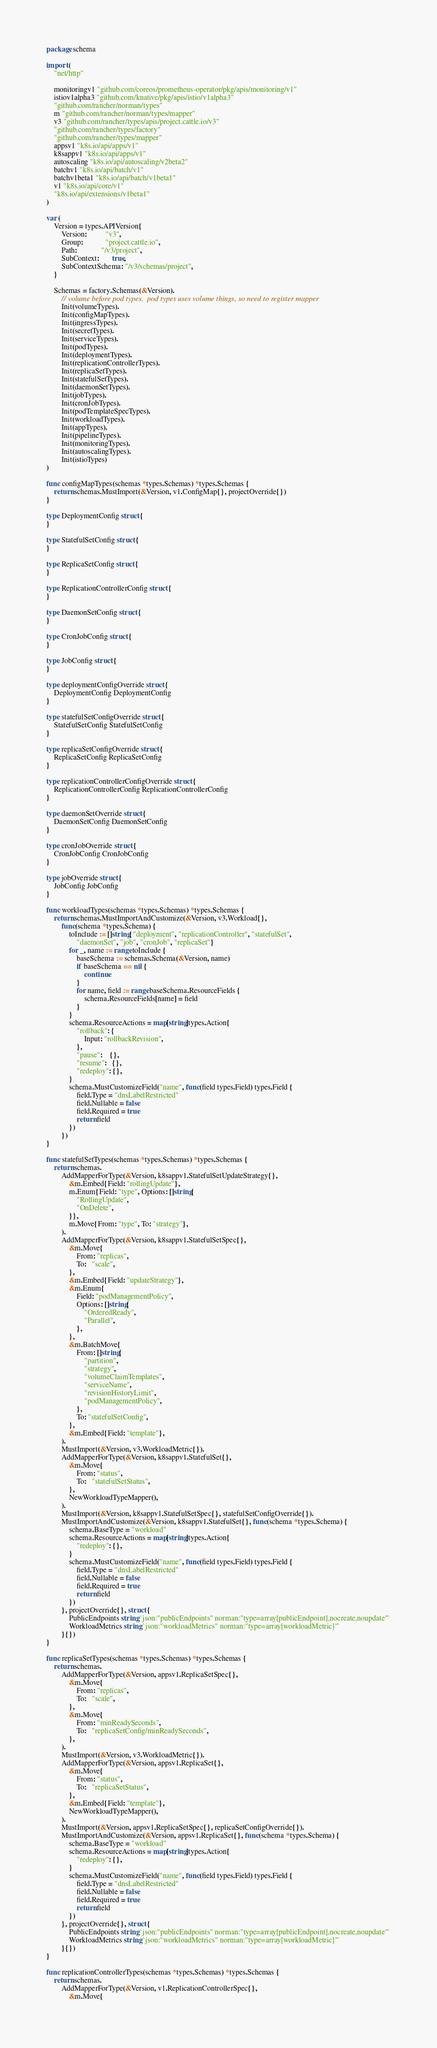Convert code to text. <code><loc_0><loc_0><loc_500><loc_500><_Go_>package schema

import (
	"net/http"

	monitoringv1 "github.com/coreos/prometheus-operator/pkg/apis/monitoring/v1"
	istiov1alpha3 "github.com/knative/pkg/apis/istio/v1alpha3"
	"github.com/rancher/norman/types"
	m "github.com/rancher/norman/types/mapper"
	v3 "github.com/rancher/types/apis/project.cattle.io/v3"
	"github.com/rancher/types/factory"
	"github.com/rancher/types/mapper"
	appsv1 "k8s.io/api/apps/v1"
	k8sappv1 "k8s.io/api/apps/v1"
	autoscaling "k8s.io/api/autoscaling/v2beta2"
	batchv1 "k8s.io/api/batch/v1"
	batchv1beta1 "k8s.io/api/batch/v1beta1"
	v1 "k8s.io/api/core/v1"
	"k8s.io/api/extensions/v1beta1"
)

var (
	Version = types.APIVersion{
		Version:          "v3",
		Group:            "project.cattle.io",
		Path:             "/v3/project",
		SubContext:       true,
		SubContextSchema: "/v3/schemas/project",
	}

	Schemas = factory.Schemas(&Version).
		// volume before pod types.  pod types uses volume things, so need to register mapper
		Init(volumeTypes).
		Init(configMapTypes).
		Init(ingressTypes).
		Init(secretTypes).
		Init(serviceTypes).
		Init(podTypes).
		Init(deploymentTypes).
		Init(replicationControllerTypes).
		Init(replicaSetTypes).
		Init(statefulSetTypes).
		Init(daemonSetTypes).
		Init(jobTypes).
		Init(cronJobTypes).
		Init(podTemplateSpecTypes).
		Init(workloadTypes).
		Init(appTypes).
		Init(pipelineTypes).
		Init(monitoringTypes).
		Init(autoscalingTypes).
		Init(istioTypes)
)

func configMapTypes(schemas *types.Schemas) *types.Schemas {
	return schemas.MustImport(&Version, v1.ConfigMap{}, projectOverride{})
}

type DeploymentConfig struct {
}

type StatefulSetConfig struct {
}

type ReplicaSetConfig struct {
}

type ReplicationControllerConfig struct {
}

type DaemonSetConfig struct {
}

type CronJobConfig struct {
}

type JobConfig struct {
}

type deploymentConfigOverride struct {
	DeploymentConfig DeploymentConfig
}

type statefulSetConfigOverride struct {
	StatefulSetConfig StatefulSetConfig
}

type replicaSetConfigOverride struct {
	ReplicaSetConfig ReplicaSetConfig
}

type replicationControllerConfigOverride struct {
	ReplicationControllerConfig ReplicationControllerConfig
}

type daemonSetOverride struct {
	DaemonSetConfig DaemonSetConfig
}

type cronJobOverride struct {
	CronJobConfig CronJobConfig
}

type jobOverride struct {
	JobConfig JobConfig
}

func workloadTypes(schemas *types.Schemas) *types.Schemas {
	return schemas.MustImportAndCustomize(&Version, v3.Workload{},
		func(schema *types.Schema) {
			toInclude := []string{"deployment", "replicationController", "statefulSet",
				"daemonSet", "job", "cronJob", "replicaSet"}
			for _, name := range toInclude {
				baseSchema := schemas.Schema(&Version, name)
				if baseSchema == nil {
					continue
				}
				for name, field := range baseSchema.ResourceFields {
					schema.ResourceFields[name] = field
				}
			}
			schema.ResourceActions = map[string]types.Action{
				"rollback": {
					Input: "rollbackRevision",
				},
				"pause":    {},
				"resume":   {},
				"redeploy": {},
			}
			schema.MustCustomizeField("name", func(field types.Field) types.Field {
				field.Type = "dnsLabelRestricted"
				field.Nullable = false
				field.Required = true
				return field
			})
		})
}

func statefulSetTypes(schemas *types.Schemas) *types.Schemas {
	return schemas.
		AddMapperForType(&Version, k8sappv1.StatefulSetUpdateStrategy{},
			&m.Embed{Field: "rollingUpdate"},
			m.Enum{Field: "type", Options: []string{
				"RollingUpdate",
				"OnDelete",
			}},
			m.Move{From: "type", To: "strategy"},
		).
		AddMapperForType(&Version, k8sappv1.StatefulSetSpec{},
			&m.Move{
				From: "replicas",
				To:   "scale",
			},
			&m.Embed{Field: "updateStrategy"},
			&m.Enum{
				Field: "podManagementPolicy",
				Options: []string{
					"OrderedReady",
					"Parallel",
				},
			},
			&m.BatchMove{
				From: []string{
					"partition",
					"strategy",
					"volumeClaimTemplates",
					"serviceName",
					"revisionHistoryLimit",
					"podManagementPolicy",
				},
				To: "statefulSetConfig",
			},
			&m.Embed{Field: "template"},
		).
		MustImport(&Version, v3.WorkloadMetric{}).
		AddMapperForType(&Version, k8sappv1.StatefulSet{},
			&m.Move{
				From: "status",
				To:   "statefulSetStatus",
			},
			NewWorkloadTypeMapper(),
		).
		MustImport(&Version, k8sappv1.StatefulSetSpec{}, statefulSetConfigOverride{}).
		MustImportAndCustomize(&Version, k8sappv1.StatefulSet{}, func(schema *types.Schema) {
			schema.BaseType = "workload"
			schema.ResourceActions = map[string]types.Action{
				"redeploy": {},
			}
			schema.MustCustomizeField("name", func(field types.Field) types.Field {
				field.Type = "dnsLabelRestricted"
				field.Nullable = false
				field.Required = true
				return field
			})
		}, projectOverride{}, struct {
			PublicEndpoints string `json:"publicEndpoints" norman:"type=array[publicEndpoint],nocreate,noupdate"`
			WorkloadMetrics string `json:"workloadMetrics" norman:"type=array[workloadMetric]"`
		}{})
}

func replicaSetTypes(schemas *types.Schemas) *types.Schemas {
	return schemas.
		AddMapperForType(&Version, appsv1.ReplicaSetSpec{},
			&m.Move{
				From: "replicas",
				To:   "scale",
			},
			&m.Move{
				From: "minReadySeconds",
				To:   "replicaSetConfig/minReadySeconds",
			},
		).
		MustImport(&Version, v3.WorkloadMetric{}).
		AddMapperForType(&Version, appsv1.ReplicaSet{},
			&m.Move{
				From: "status",
				To:   "replicaSetStatus",
			},
			&m.Embed{Field: "template"},
			NewWorkloadTypeMapper(),
		).
		MustImport(&Version, appsv1.ReplicaSetSpec{}, replicaSetConfigOverride{}).
		MustImportAndCustomize(&Version, appsv1.ReplicaSet{}, func(schema *types.Schema) {
			schema.BaseType = "workload"
			schema.ResourceActions = map[string]types.Action{
				"redeploy": {},
			}
			schema.MustCustomizeField("name", func(field types.Field) types.Field {
				field.Type = "dnsLabelRestricted"
				field.Nullable = false
				field.Required = true
				return field
			})
		}, projectOverride{}, struct {
			PublicEndpoints string `json:"publicEndpoints" norman:"type=array[publicEndpoint],nocreate,noupdate"`
			WorkloadMetrics string `json:"workloadMetrics" norman:"type=array[workloadMetric]"`
		}{})
}

func replicationControllerTypes(schemas *types.Schemas) *types.Schemas {
	return schemas.
		AddMapperForType(&Version, v1.ReplicationControllerSpec{},
			&m.Move{</code> 